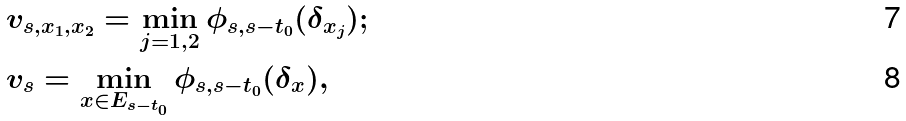<formula> <loc_0><loc_0><loc_500><loc_500>& v _ { s , x _ { 1 } , x _ { 2 } } = \min _ { j = 1 , 2 } \phi _ { s , s - t _ { 0 } } ( \delta _ { x _ { j } } ) ; \\ & v _ { s } = \min _ { x \in E _ { s - t _ { 0 } } } \phi _ { s , s - t _ { 0 } } ( \delta _ { x } ) ,</formula> 